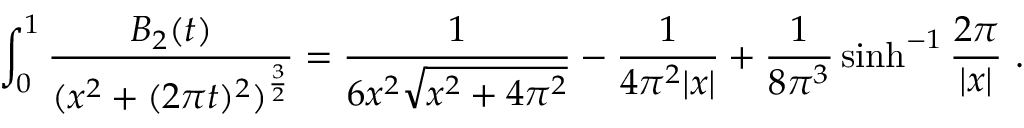Convert formula to latex. <formula><loc_0><loc_0><loc_500><loc_500>\int _ { 0 } ^ { 1 } { \frac { B _ { 2 } ( t ) } { ( x ^ { 2 } + ( 2 \pi t ) ^ { 2 } ) ^ { { \frac { 3 } { 2 } } } } } = { \frac { 1 } { 6 x ^ { 2 } \sqrt { x ^ { 2 } + 4 \pi ^ { 2 } } } } - { \frac { 1 } { 4 \pi ^ { 2 } | x | } } + { \frac { 1 } { 8 \pi ^ { 3 } } } \sinh ^ { - 1 } { \frac { 2 \pi } { | x | } } \ .</formula> 